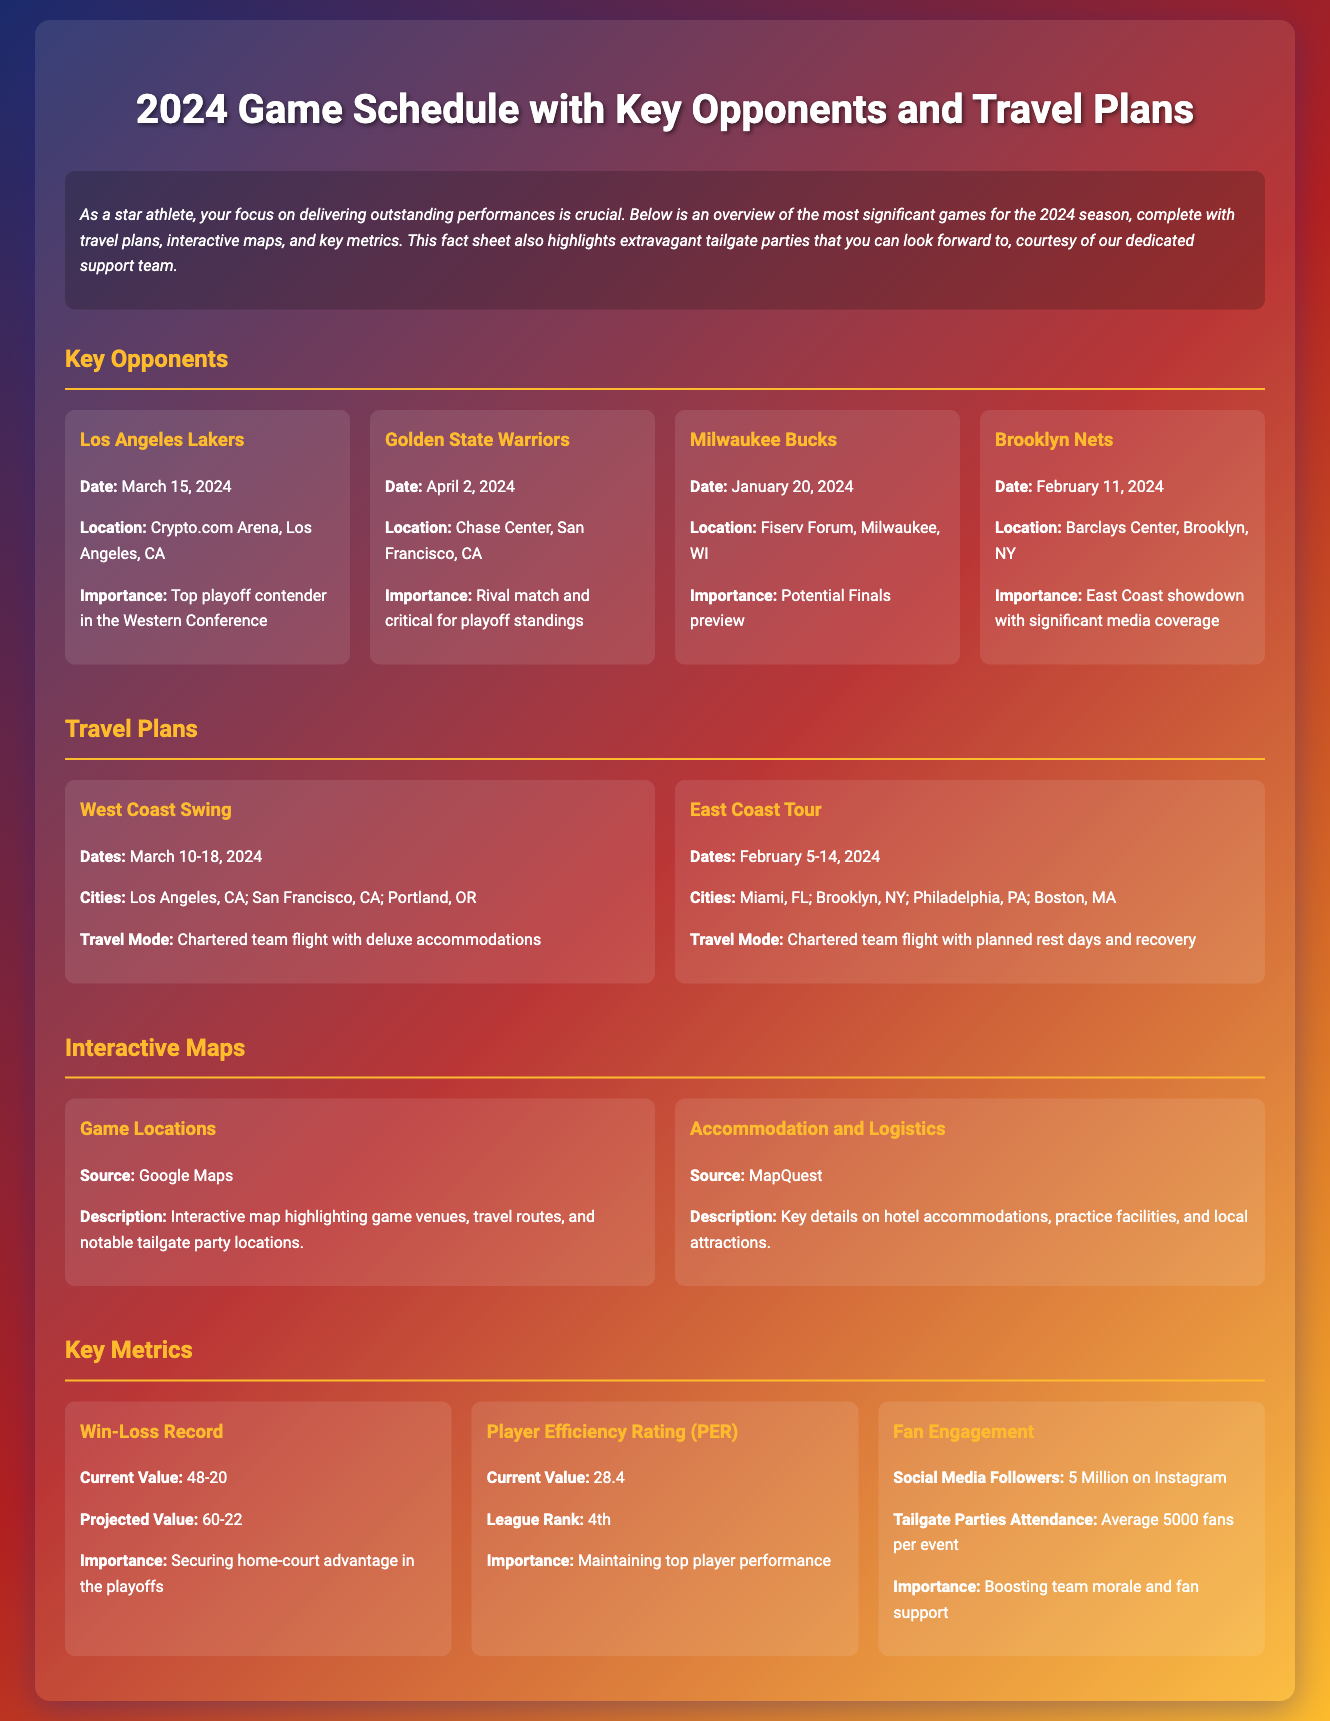What is the date of the game against the Los Angeles Lakers? The date of the game against the Los Angeles Lakers is found under the Key Opponents section, which lists March 15, 2024.
Answer: March 15, 2024 Where will the game against the Golden State Warriors take place? The location for the game against the Golden State Warriors is provided, which is Chase Center, San Francisco, CA.
Answer: Chase Center, San Francisco, CA What is the importance of the game against the Milwaukee Bucks? The importance of the game against the Milwaukee Bucks is specified as a potential Finals preview.
Answer: Potential Finals preview How many cities are included in the East Coast Tour? The East Coast Tour lists four cities in the Travel Plans section, which are Miami, Brooklyn, Philadelphia, and Boston.
Answer: Four cities What is the projected win-loss record? The projected value for the win-loss record can be found in the Key Metrics section, indicating 60-22.
Answer: 60-22 Which interactive map source highlights game venues? The source of the interactive map that highlights game venues is noted as Google Maps.
Answer: Google Maps What is the average attendance for tailgate parties? The average attendance for tailgate parties is specified in the Key Metrics section, which is 5000 fans per event.
Answer: 5000 fans What are the dates for the West Coast Swing? The dates for the West Coast Swing are mentioned in the Travel Plans section, listed as March 10-18, 2024.
Answer: March 10-18, 2024 What is the Player Efficiency Rating mentioned in the document? The current Player Efficiency Rating is detailed in the Key Metrics section as 28.4.
Answer: 28.4 